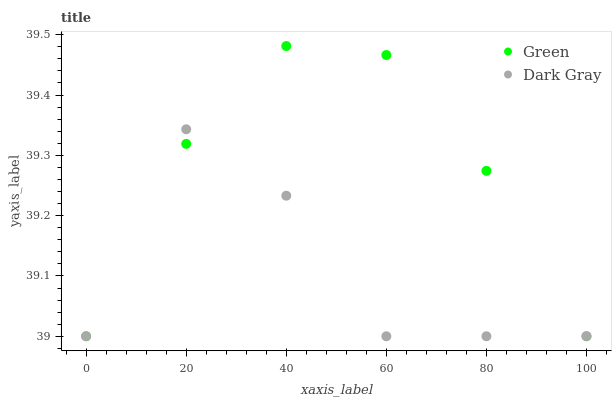Does Dark Gray have the minimum area under the curve?
Answer yes or no. Yes. Does Green have the maximum area under the curve?
Answer yes or no. Yes. Does Green have the minimum area under the curve?
Answer yes or no. No. Is Green the smoothest?
Answer yes or no. Yes. Is Dark Gray the roughest?
Answer yes or no. Yes. Is Green the roughest?
Answer yes or no. No. Does Dark Gray have the lowest value?
Answer yes or no. Yes. Does Green have the highest value?
Answer yes or no. Yes. Does Dark Gray intersect Green?
Answer yes or no. Yes. Is Dark Gray less than Green?
Answer yes or no. No. Is Dark Gray greater than Green?
Answer yes or no. No. 